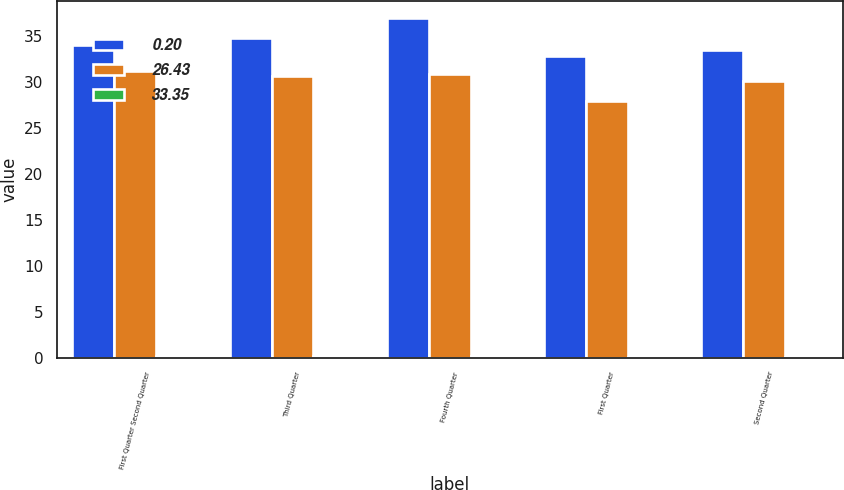Convert chart to OTSL. <chart><loc_0><loc_0><loc_500><loc_500><stacked_bar_chart><ecel><fcel>First Quarter Second Quarter<fcel>Third Quarter<fcel>Fourth Quarter<fcel>First Quarter<fcel>Second Quarter<nl><fcel>0.2<fcel>34.08<fcel>34.8<fcel>36.97<fcel>32.79<fcel>33.54<nl><fcel>26.43<fcel>31.24<fcel>30.71<fcel>30.89<fcel>27.95<fcel>30.07<nl><fcel>33.35<fcel>0.2<fcel>0.2<fcel>0.2<fcel>0.05<fcel>0.05<nl></chart> 